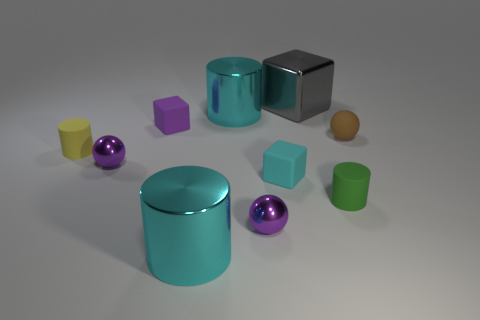There is another tiny thing that is the same shape as the green matte thing; what material is it?
Keep it short and to the point. Rubber. How many things are cyan objects behind the small purple block or big yellow rubber cylinders?
Ensure brevity in your answer.  1. What size is the cyan shiny object in front of the tiny brown ball?
Ensure brevity in your answer.  Large. What is the material of the yellow object?
Ensure brevity in your answer.  Rubber. The big metal thing in front of the big metallic cylinder behind the cyan matte cube is what shape?
Make the answer very short. Cylinder. How many other objects are there of the same shape as the yellow matte thing?
Provide a succinct answer. 3. There is a small yellow rubber cylinder; are there any large gray metal blocks in front of it?
Provide a succinct answer. No. What color is the shiny block?
Offer a very short reply. Gray. There is a rubber ball; is it the same color as the matte cylinder that is right of the large gray cube?
Ensure brevity in your answer.  No. Is there a block that has the same size as the yellow cylinder?
Offer a terse response. Yes. 